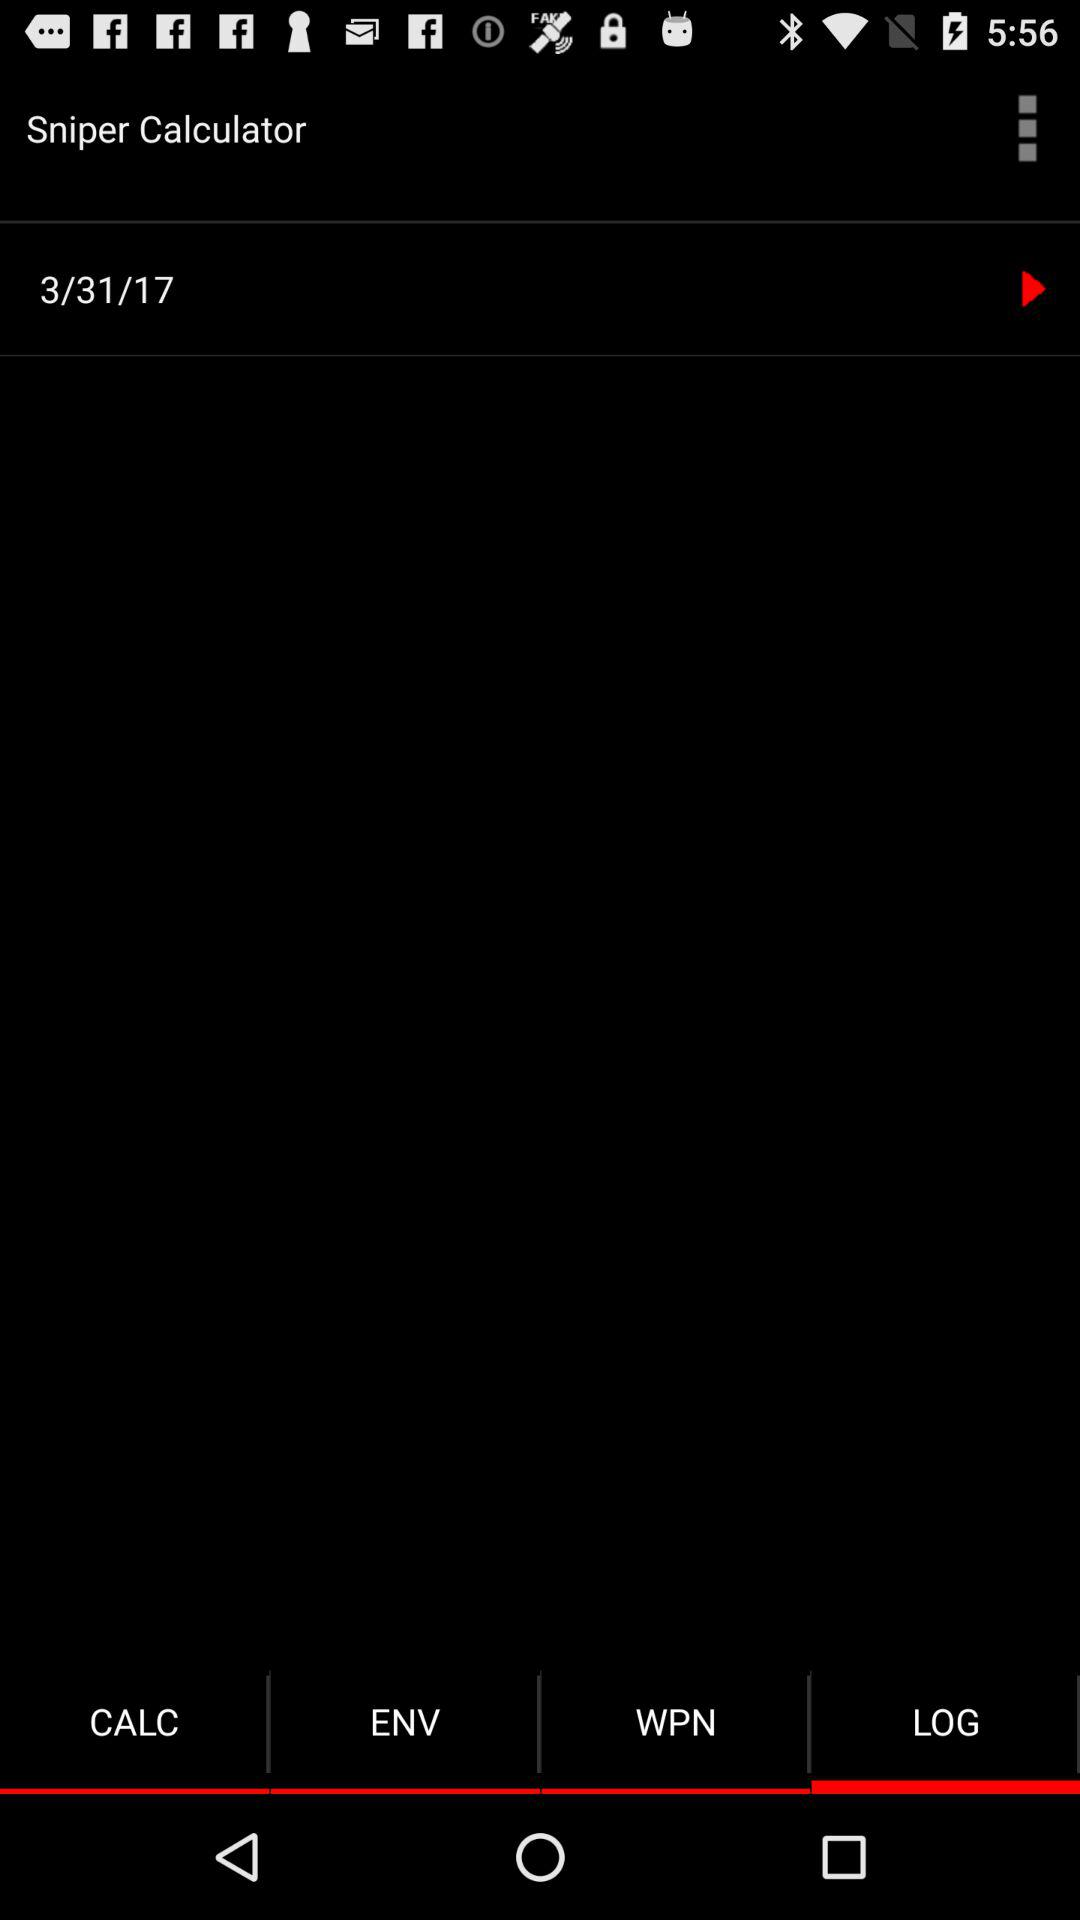What is the mentioned date? The mentioned date is March 31, 2017. 